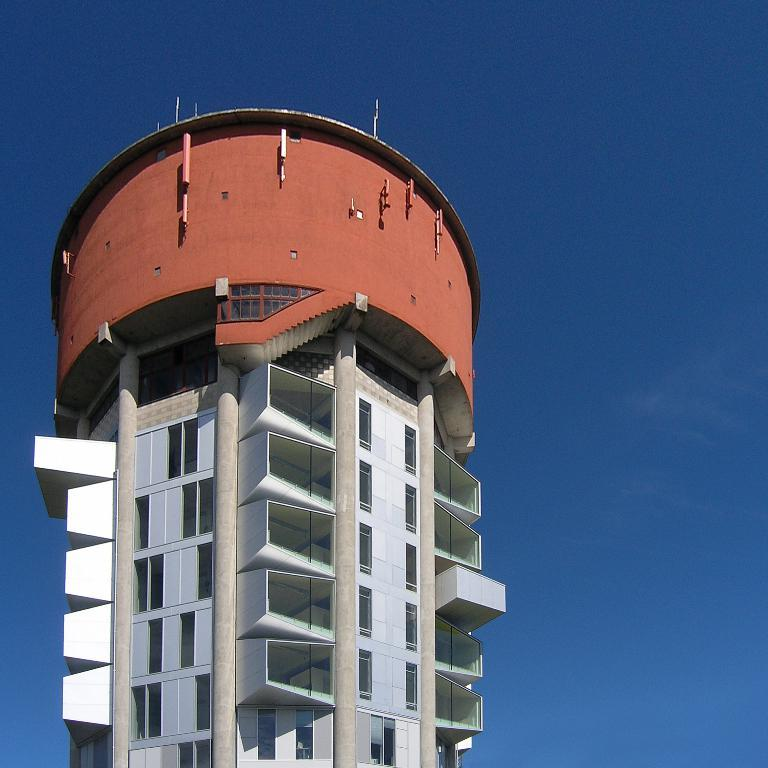What is the main structure in the front of the image? There is a building in the front of the image. What feature can be seen on the building? The building has windows. What is visible at the top of the image? The sky is visible at the top of the image. How many eyes can be seen on the building in the image? There are no eyes present on the building in the image. What type of cake is being served in the image? There is no cake present in the image. 